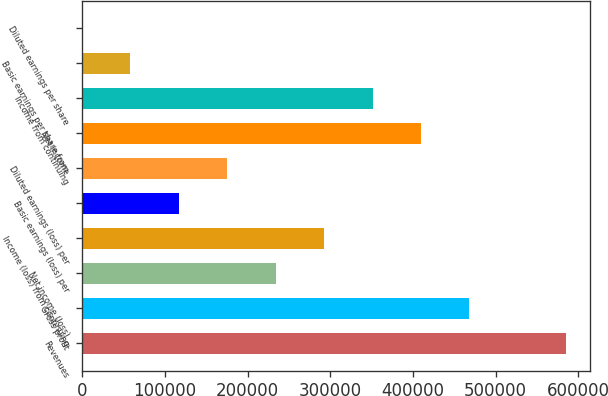<chart> <loc_0><loc_0><loc_500><loc_500><bar_chart><fcel>Revenues<fcel>Gross profit<fcel>Net income (loss)<fcel>Income (loss) from continuing<fcel>Basic earnings (loss) per<fcel>Diluted earnings (loss) per<fcel>Net income<fcel>Income from continuing<fcel>Basic earnings per share from<fcel>Diluted earnings per share<nl><fcel>585229<fcel>468183<fcel>234092<fcel>292615<fcel>117046<fcel>175569<fcel>409660<fcel>351137<fcel>58523.1<fcel>0.18<nl></chart> 